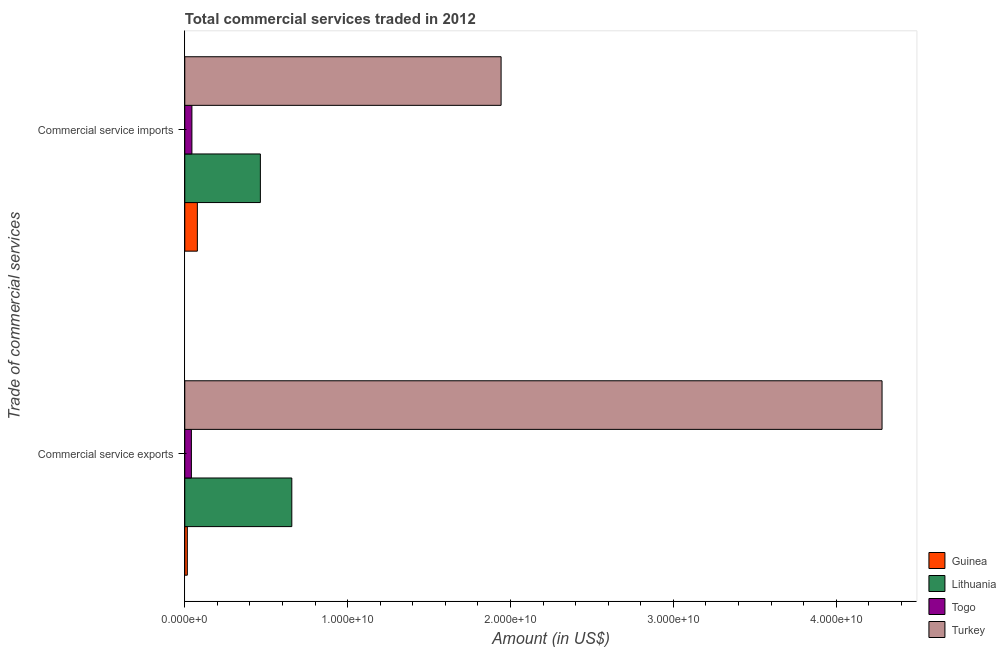How many different coloured bars are there?
Provide a short and direct response. 4. How many groups of bars are there?
Your answer should be very brief. 2. How many bars are there on the 1st tick from the bottom?
Your answer should be very brief. 4. What is the label of the 2nd group of bars from the top?
Ensure brevity in your answer.  Commercial service exports. What is the amount of commercial service imports in Guinea?
Your response must be concise. 7.72e+08. Across all countries, what is the maximum amount of commercial service exports?
Provide a succinct answer. 4.28e+1. Across all countries, what is the minimum amount of commercial service exports?
Make the answer very short. 1.56e+08. In which country was the amount of commercial service exports minimum?
Give a very brief answer. Guinea. What is the total amount of commercial service exports in the graph?
Your answer should be very brief. 4.99e+1. What is the difference between the amount of commercial service exports in Lithuania and that in Togo?
Make the answer very short. 6.17e+09. What is the difference between the amount of commercial service exports in Turkey and the amount of commercial service imports in Guinea?
Offer a terse response. 4.20e+1. What is the average amount of commercial service exports per country?
Offer a very short reply. 1.25e+1. What is the difference between the amount of commercial service exports and amount of commercial service imports in Guinea?
Your response must be concise. -6.16e+08. In how many countries, is the amount of commercial service exports greater than 36000000000 US$?
Keep it short and to the point. 1. What is the ratio of the amount of commercial service exports in Turkey to that in Togo?
Offer a very short reply. 105.61. Is the amount of commercial service exports in Turkey less than that in Guinea?
Your answer should be very brief. No. What does the 3rd bar from the top in Commercial service exports represents?
Provide a succinct answer. Lithuania. How many bars are there?
Ensure brevity in your answer.  8. Are all the bars in the graph horizontal?
Your answer should be compact. Yes. What is the difference between two consecutive major ticks on the X-axis?
Your answer should be very brief. 1.00e+1. Are the values on the major ticks of X-axis written in scientific E-notation?
Your answer should be compact. Yes. Where does the legend appear in the graph?
Give a very brief answer. Bottom right. How are the legend labels stacked?
Provide a succinct answer. Vertical. What is the title of the graph?
Offer a very short reply. Total commercial services traded in 2012. What is the label or title of the Y-axis?
Ensure brevity in your answer.  Trade of commercial services. What is the Amount (in US$) of Guinea in Commercial service exports?
Your answer should be very brief. 1.56e+08. What is the Amount (in US$) of Lithuania in Commercial service exports?
Your response must be concise. 6.57e+09. What is the Amount (in US$) in Togo in Commercial service exports?
Make the answer very short. 4.05e+08. What is the Amount (in US$) in Turkey in Commercial service exports?
Provide a short and direct response. 4.28e+1. What is the Amount (in US$) in Guinea in Commercial service imports?
Offer a very short reply. 7.72e+08. What is the Amount (in US$) of Lithuania in Commercial service imports?
Make the answer very short. 4.64e+09. What is the Amount (in US$) in Togo in Commercial service imports?
Your response must be concise. 4.37e+08. What is the Amount (in US$) of Turkey in Commercial service imports?
Offer a terse response. 1.94e+1. Across all Trade of commercial services, what is the maximum Amount (in US$) of Guinea?
Keep it short and to the point. 7.72e+08. Across all Trade of commercial services, what is the maximum Amount (in US$) of Lithuania?
Offer a terse response. 6.57e+09. Across all Trade of commercial services, what is the maximum Amount (in US$) of Togo?
Make the answer very short. 4.37e+08. Across all Trade of commercial services, what is the maximum Amount (in US$) of Turkey?
Provide a short and direct response. 4.28e+1. Across all Trade of commercial services, what is the minimum Amount (in US$) of Guinea?
Give a very brief answer. 1.56e+08. Across all Trade of commercial services, what is the minimum Amount (in US$) of Lithuania?
Make the answer very short. 4.64e+09. Across all Trade of commercial services, what is the minimum Amount (in US$) of Togo?
Provide a short and direct response. 4.05e+08. Across all Trade of commercial services, what is the minimum Amount (in US$) in Turkey?
Your response must be concise. 1.94e+1. What is the total Amount (in US$) in Guinea in the graph?
Keep it short and to the point. 9.28e+08. What is the total Amount (in US$) in Lithuania in the graph?
Ensure brevity in your answer.  1.12e+1. What is the total Amount (in US$) in Togo in the graph?
Provide a succinct answer. 8.43e+08. What is the total Amount (in US$) of Turkey in the graph?
Provide a short and direct response. 6.22e+1. What is the difference between the Amount (in US$) of Guinea in Commercial service exports and that in Commercial service imports?
Keep it short and to the point. -6.16e+08. What is the difference between the Amount (in US$) of Lithuania in Commercial service exports and that in Commercial service imports?
Your response must be concise. 1.93e+09. What is the difference between the Amount (in US$) of Togo in Commercial service exports and that in Commercial service imports?
Provide a succinct answer. -3.18e+07. What is the difference between the Amount (in US$) of Turkey in Commercial service exports and that in Commercial service imports?
Your response must be concise. 2.34e+1. What is the difference between the Amount (in US$) of Guinea in Commercial service exports and the Amount (in US$) of Lithuania in Commercial service imports?
Ensure brevity in your answer.  -4.49e+09. What is the difference between the Amount (in US$) of Guinea in Commercial service exports and the Amount (in US$) of Togo in Commercial service imports?
Make the answer very short. -2.81e+08. What is the difference between the Amount (in US$) of Guinea in Commercial service exports and the Amount (in US$) of Turkey in Commercial service imports?
Your answer should be compact. -1.93e+1. What is the difference between the Amount (in US$) of Lithuania in Commercial service exports and the Amount (in US$) of Togo in Commercial service imports?
Keep it short and to the point. 6.13e+09. What is the difference between the Amount (in US$) in Lithuania in Commercial service exports and the Amount (in US$) in Turkey in Commercial service imports?
Make the answer very short. -1.28e+1. What is the difference between the Amount (in US$) of Togo in Commercial service exports and the Amount (in US$) of Turkey in Commercial service imports?
Offer a very short reply. -1.90e+1. What is the average Amount (in US$) of Guinea per Trade of commercial services?
Your answer should be very brief. 4.64e+08. What is the average Amount (in US$) in Lithuania per Trade of commercial services?
Provide a succinct answer. 5.61e+09. What is the average Amount (in US$) of Togo per Trade of commercial services?
Give a very brief answer. 4.21e+08. What is the average Amount (in US$) of Turkey per Trade of commercial services?
Your response must be concise. 3.11e+1. What is the difference between the Amount (in US$) in Guinea and Amount (in US$) in Lithuania in Commercial service exports?
Your response must be concise. -6.42e+09. What is the difference between the Amount (in US$) in Guinea and Amount (in US$) in Togo in Commercial service exports?
Provide a short and direct response. -2.49e+08. What is the difference between the Amount (in US$) of Guinea and Amount (in US$) of Turkey in Commercial service exports?
Give a very brief answer. -4.27e+1. What is the difference between the Amount (in US$) in Lithuania and Amount (in US$) in Togo in Commercial service exports?
Your answer should be compact. 6.17e+09. What is the difference between the Amount (in US$) in Lithuania and Amount (in US$) in Turkey in Commercial service exports?
Provide a short and direct response. -3.62e+1. What is the difference between the Amount (in US$) of Togo and Amount (in US$) of Turkey in Commercial service exports?
Offer a terse response. -4.24e+1. What is the difference between the Amount (in US$) of Guinea and Amount (in US$) of Lithuania in Commercial service imports?
Provide a succinct answer. -3.87e+09. What is the difference between the Amount (in US$) of Guinea and Amount (in US$) of Togo in Commercial service imports?
Your answer should be very brief. 3.35e+08. What is the difference between the Amount (in US$) of Guinea and Amount (in US$) of Turkey in Commercial service imports?
Ensure brevity in your answer.  -1.86e+1. What is the difference between the Amount (in US$) of Lithuania and Amount (in US$) of Togo in Commercial service imports?
Give a very brief answer. 4.20e+09. What is the difference between the Amount (in US$) of Lithuania and Amount (in US$) of Turkey in Commercial service imports?
Make the answer very short. -1.48e+1. What is the difference between the Amount (in US$) in Togo and Amount (in US$) in Turkey in Commercial service imports?
Your answer should be very brief. -1.90e+1. What is the ratio of the Amount (in US$) of Guinea in Commercial service exports to that in Commercial service imports?
Keep it short and to the point. 0.2. What is the ratio of the Amount (in US$) in Lithuania in Commercial service exports to that in Commercial service imports?
Make the answer very short. 1.42. What is the ratio of the Amount (in US$) in Togo in Commercial service exports to that in Commercial service imports?
Give a very brief answer. 0.93. What is the ratio of the Amount (in US$) of Turkey in Commercial service exports to that in Commercial service imports?
Provide a short and direct response. 2.2. What is the difference between the highest and the second highest Amount (in US$) in Guinea?
Offer a terse response. 6.16e+08. What is the difference between the highest and the second highest Amount (in US$) in Lithuania?
Your answer should be compact. 1.93e+09. What is the difference between the highest and the second highest Amount (in US$) in Togo?
Provide a short and direct response. 3.18e+07. What is the difference between the highest and the second highest Amount (in US$) in Turkey?
Offer a very short reply. 2.34e+1. What is the difference between the highest and the lowest Amount (in US$) of Guinea?
Your response must be concise. 6.16e+08. What is the difference between the highest and the lowest Amount (in US$) of Lithuania?
Offer a terse response. 1.93e+09. What is the difference between the highest and the lowest Amount (in US$) in Togo?
Offer a very short reply. 3.18e+07. What is the difference between the highest and the lowest Amount (in US$) of Turkey?
Offer a terse response. 2.34e+1. 